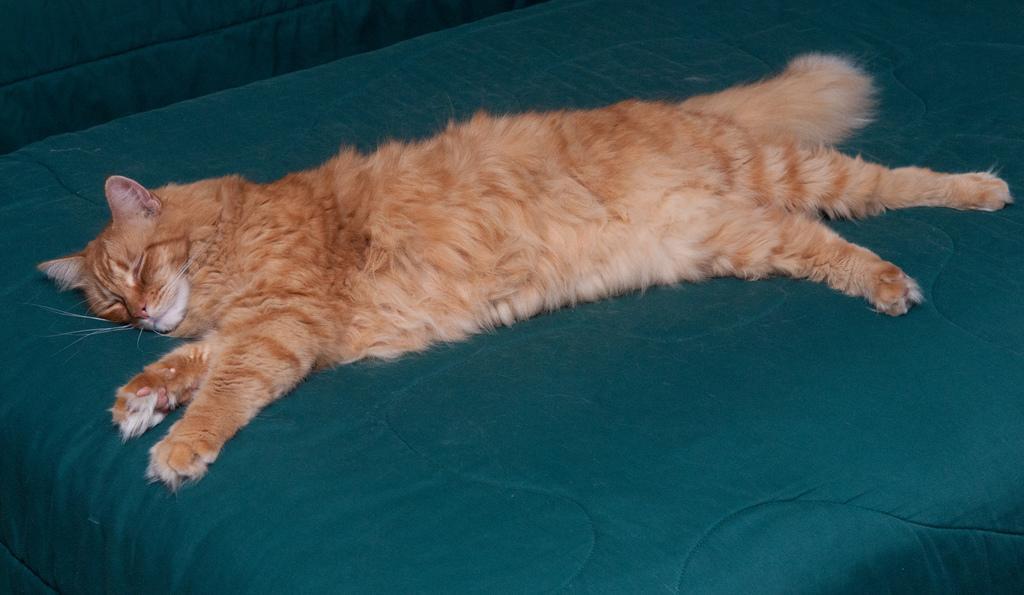How would you summarize this image in a sentence or two? In the center of the image we can see one bed. On the bed, we can see one blanket, which is in green color. On the blanket, we can see one cat lying, which is brown and cream color. 